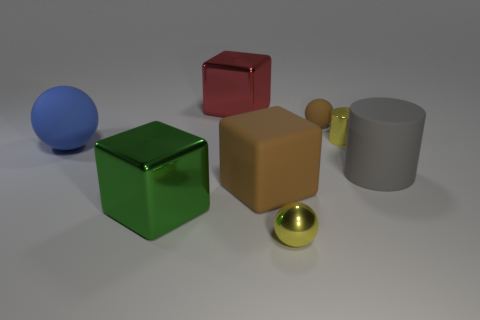Add 1 large red shiny blocks. How many objects exist? 9 Subtract all blocks. How many objects are left? 5 Subtract 0 red spheres. How many objects are left? 8 Subtract all big cylinders. Subtract all tiny balls. How many objects are left? 5 Add 3 big blue matte objects. How many big blue matte objects are left? 4 Add 6 small purple rubber things. How many small purple rubber things exist? 6 